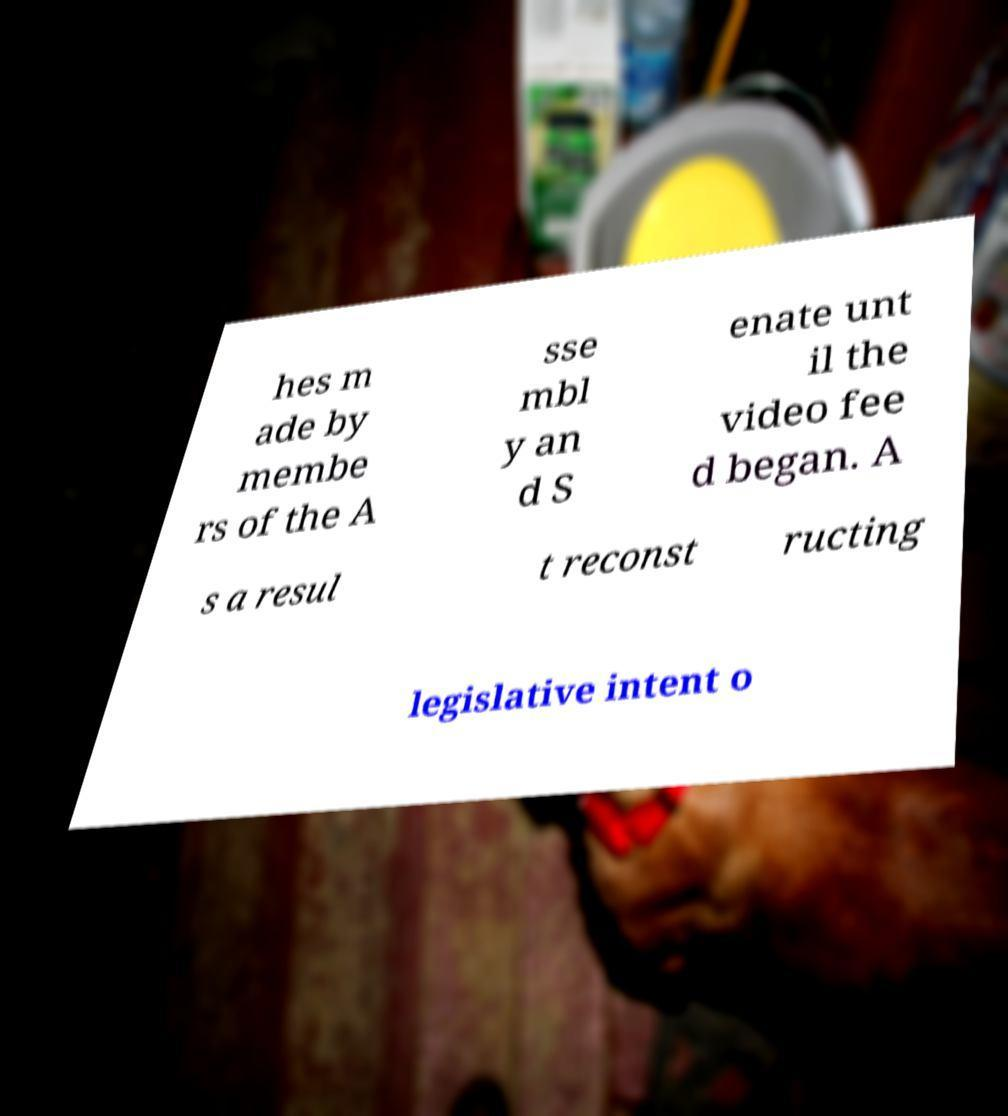What messages or text are displayed in this image? I need them in a readable, typed format. hes m ade by membe rs of the A sse mbl y an d S enate unt il the video fee d began. A s a resul t reconst ructing legislative intent o 